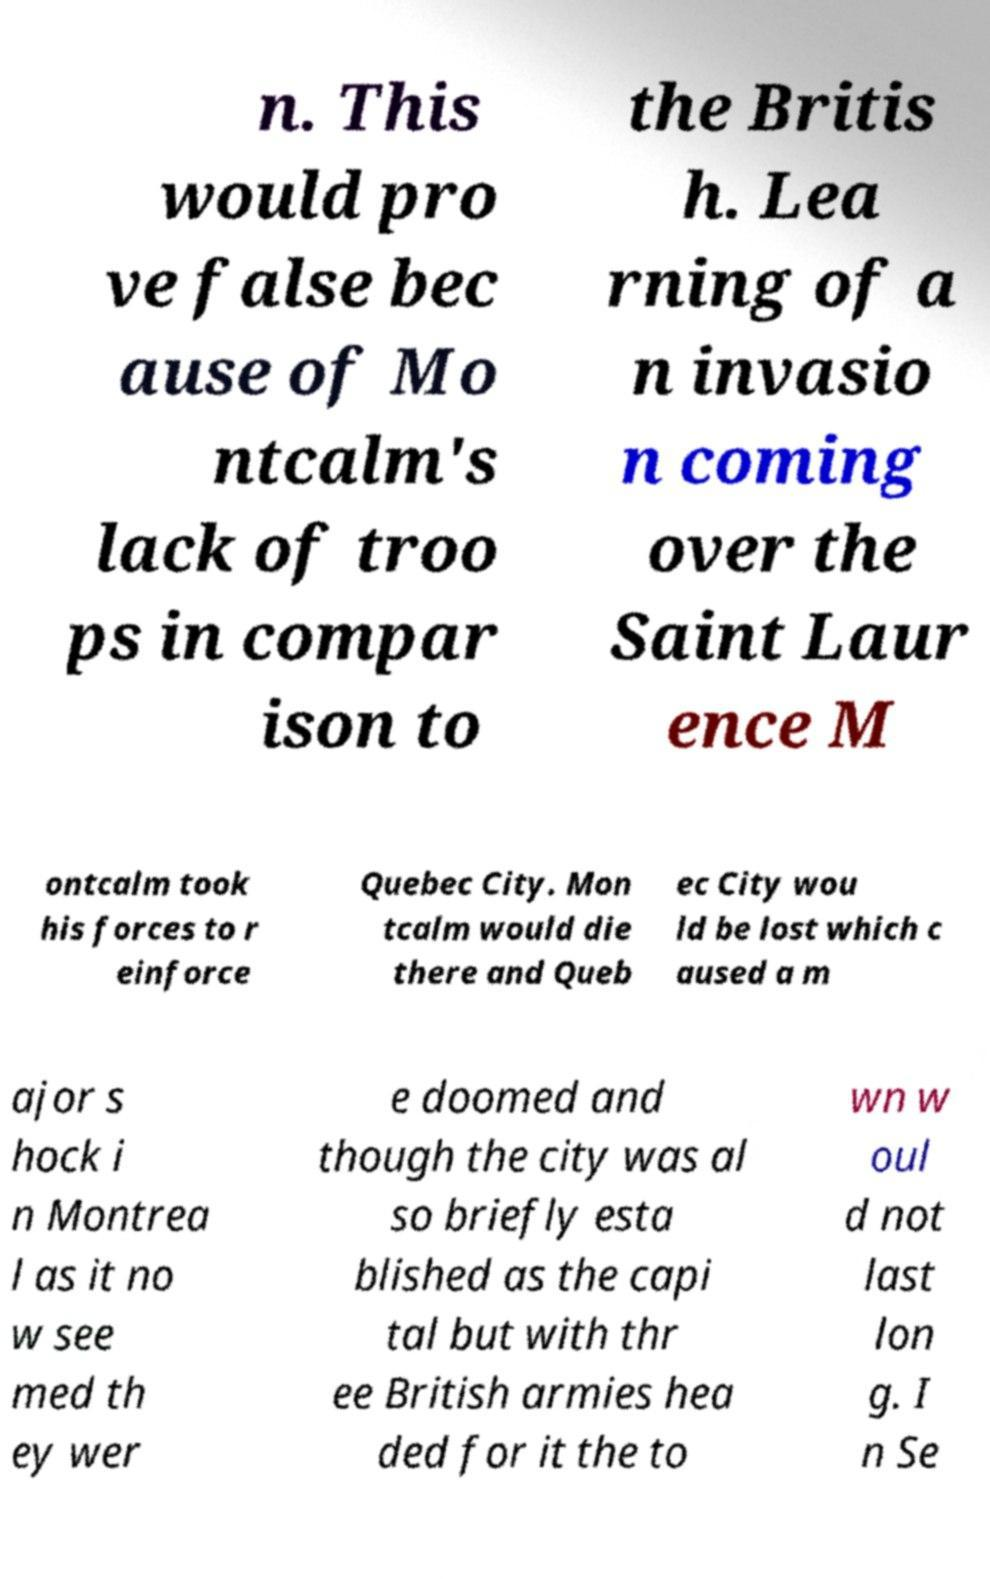Can you accurately transcribe the text from the provided image for me? n. This would pro ve false bec ause of Mo ntcalm's lack of troo ps in compar ison to the Britis h. Lea rning of a n invasio n coming over the Saint Laur ence M ontcalm took his forces to r einforce Quebec City. Mon tcalm would die there and Queb ec City wou ld be lost which c aused a m ajor s hock i n Montrea l as it no w see med th ey wer e doomed and though the city was al so briefly esta blished as the capi tal but with thr ee British armies hea ded for it the to wn w oul d not last lon g. I n Se 